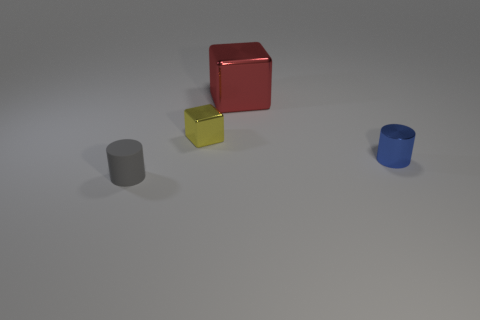Subtract all green cylinders. Subtract all red spheres. How many cylinders are left? 2 Add 4 small gray rubber cylinders. How many objects exist? 8 Subtract 0 green cylinders. How many objects are left? 4 Subtract all red matte cylinders. Subtract all large metallic objects. How many objects are left? 3 Add 1 small rubber things. How many small rubber things are left? 2 Add 2 brown blocks. How many brown blocks exist? 2 